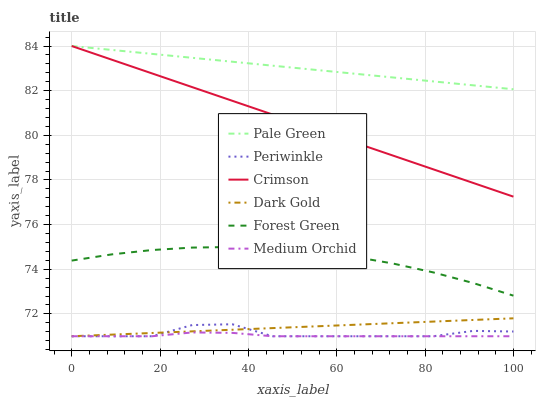Does Medium Orchid have the minimum area under the curve?
Answer yes or no. Yes. Does Pale Green have the maximum area under the curve?
Answer yes or no. Yes. Does Forest Green have the minimum area under the curve?
Answer yes or no. No. Does Forest Green have the maximum area under the curve?
Answer yes or no. No. Is Dark Gold the smoothest?
Answer yes or no. Yes. Is Periwinkle the roughest?
Answer yes or no. Yes. Is Medium Orchid the smoothest?
Answer yes or no. No. Is Medium Orchid the roughest?
Answer yes or no. No. Does Dark Gold have the lowest value?
Answer yes or no. Yes. Does Forest Green have the lowest value?
Answer yes or no. No. Does Crimson have the highest value?
Answer yes or no. Yes. Does Forest Green have the highest value?
Answer yes or no. No. Is Medium Orchid less than Crimson?
Answer yes or no. Yes. Is Forest Green greater than Periwinkle?
Answer yes or no. Yes. Does Periwinkle intersect Dark Gold?
Answer yes or no. Yes. Is Periwinkle less than Dark Gold?
Answer yes or no. No. Is Periwinkle greater than Dark Gold?
Answer yes or no. No. Does Medium Orchid intersect Crimson?
Answer yes or no. No. 